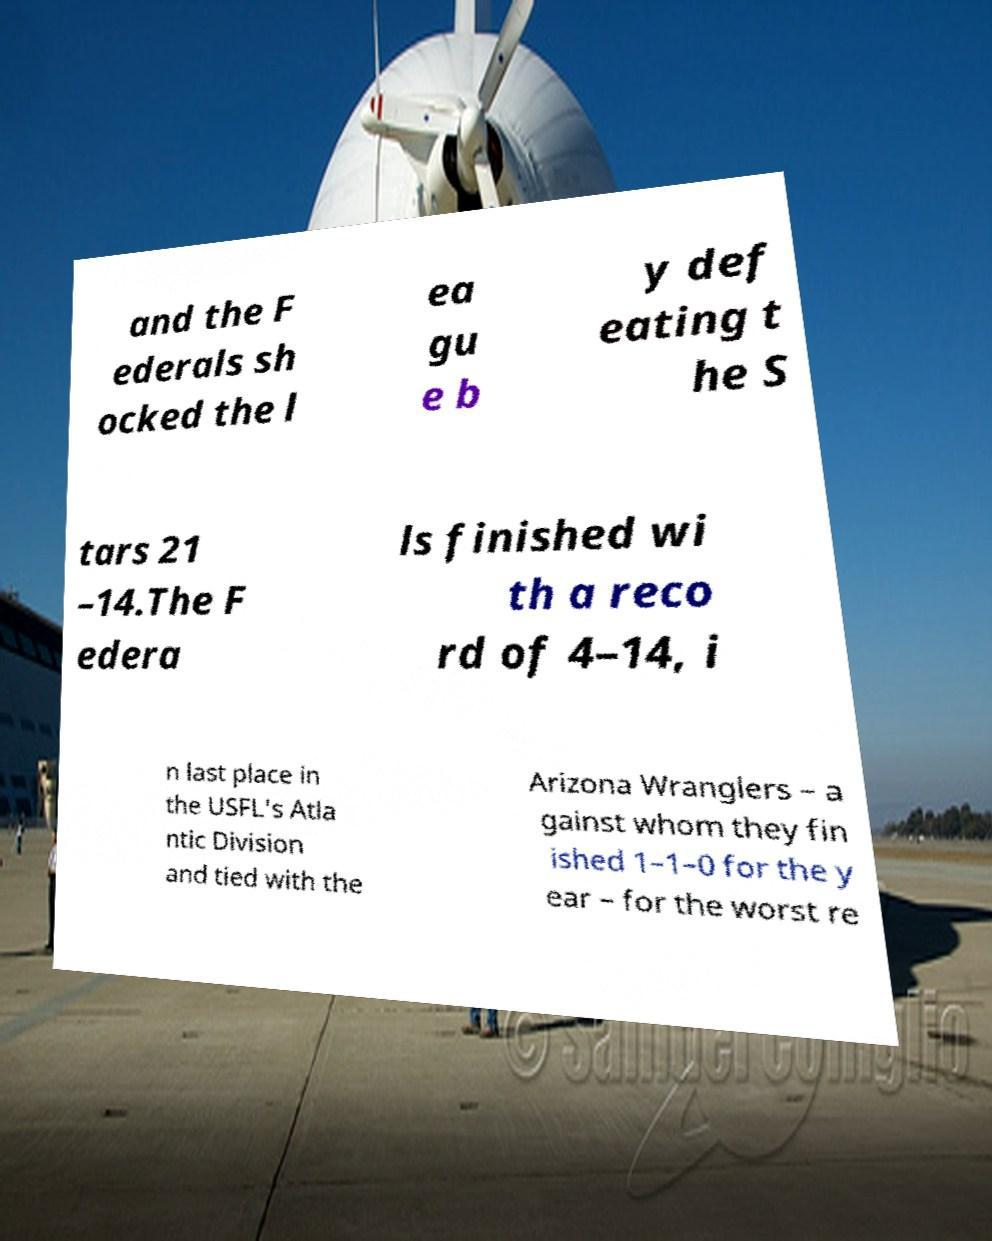Can you accurately transcribe the text from the provided image for me? and the F ederals sh ocked the l ea gu e b y def eating t he S tars 21 –14.The F edera ls finished wi th a reco rd of 4–14, i n last place in the USFL's Atla ntic Division and tied with the Arizona Wranglers – a gainst whom they fin ished 1–1–0 for the y ear – for the worst re 